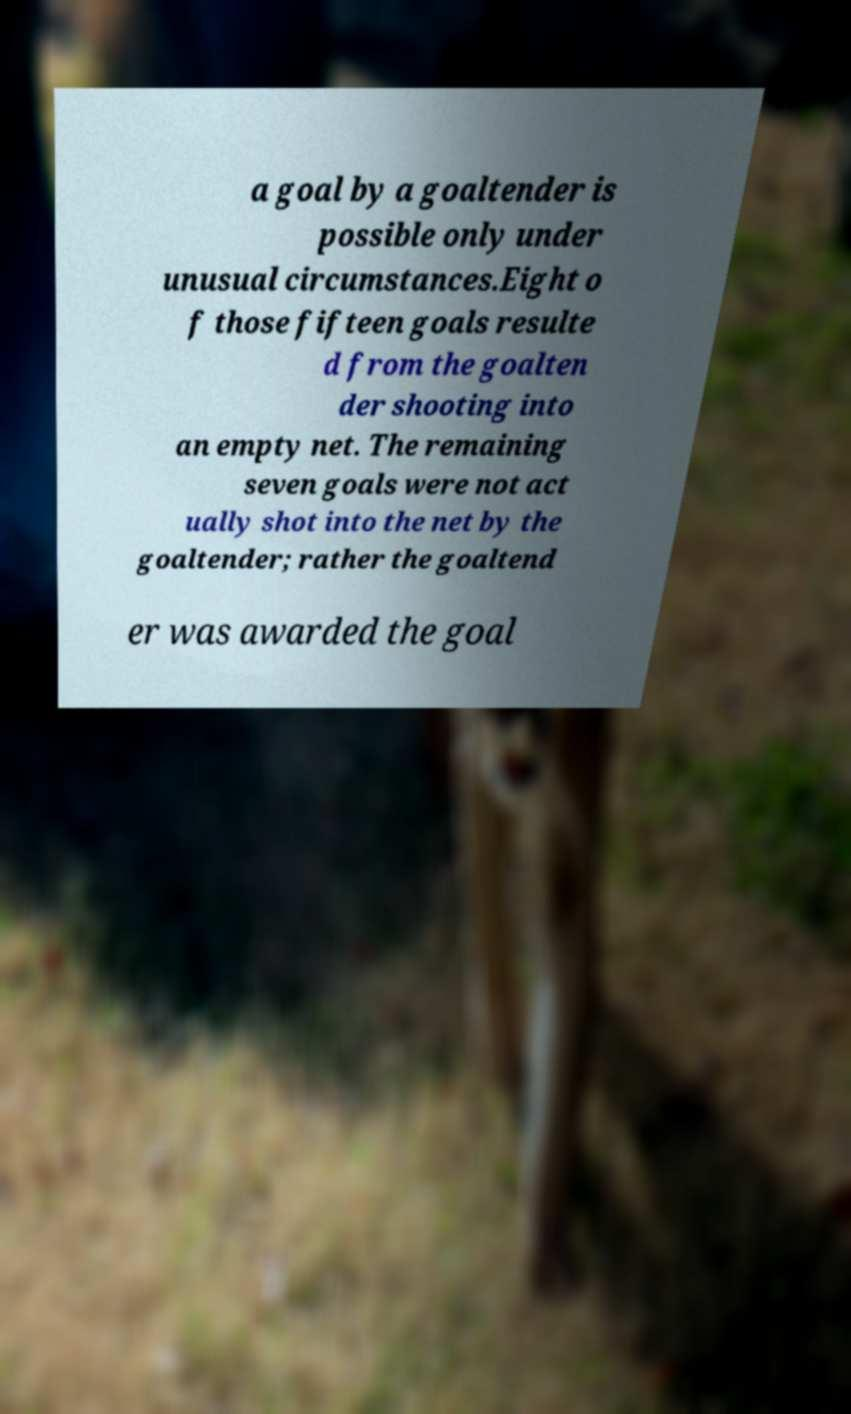Can you read and provide the text displayed in the image?This photo seems to have some interesting text. Can you extract and type it out for me? a goal by a goaltender is possible only under unusual circumstances.Eight o f those fifteen goals resulte d from the goalten der shooting into an empty net. The remaining seven goals were not act ually shot into the net by the goaltender; rather the goaltend er was awarded the goal 